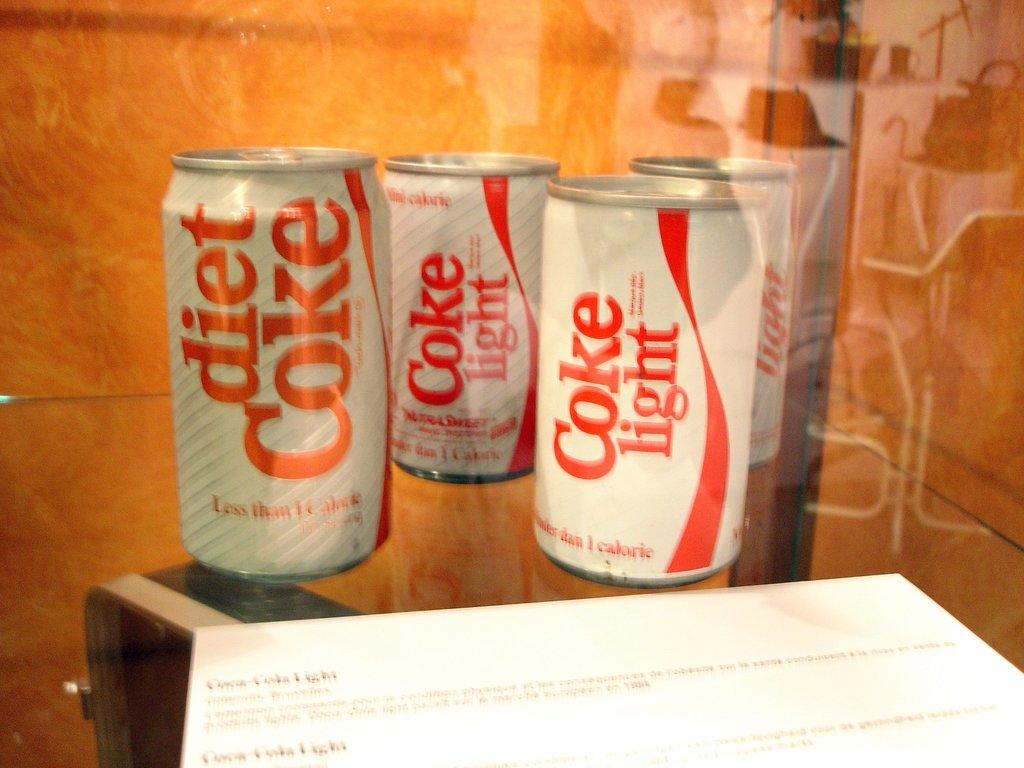<image>
Provide a brief description of the given image. The refrigerator is stacked with three cans of coke light and one can of diet coke. 